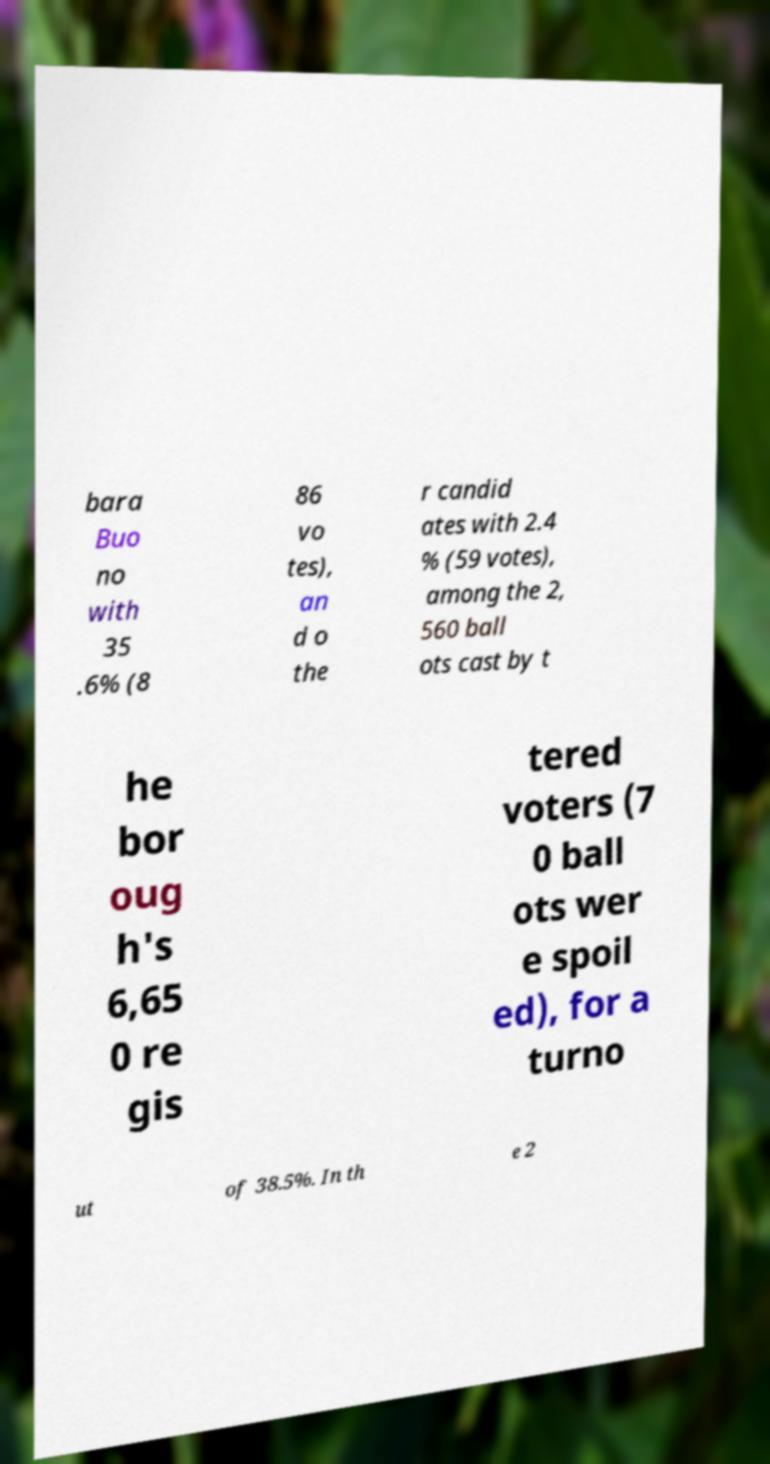Can you accurately transcribe the text from the provided image for me? bara Buo no with 35 .6% (8 86 vo tes), an d o the r candid ates with 2.4 % (59 votes), among the 2, 560 ball ots cast by t he bor oug h's 6,65 0 re gis tered voters (7 0 ball ots wer e spoil ed), for a turno ut of 38.5%. In th e 2 